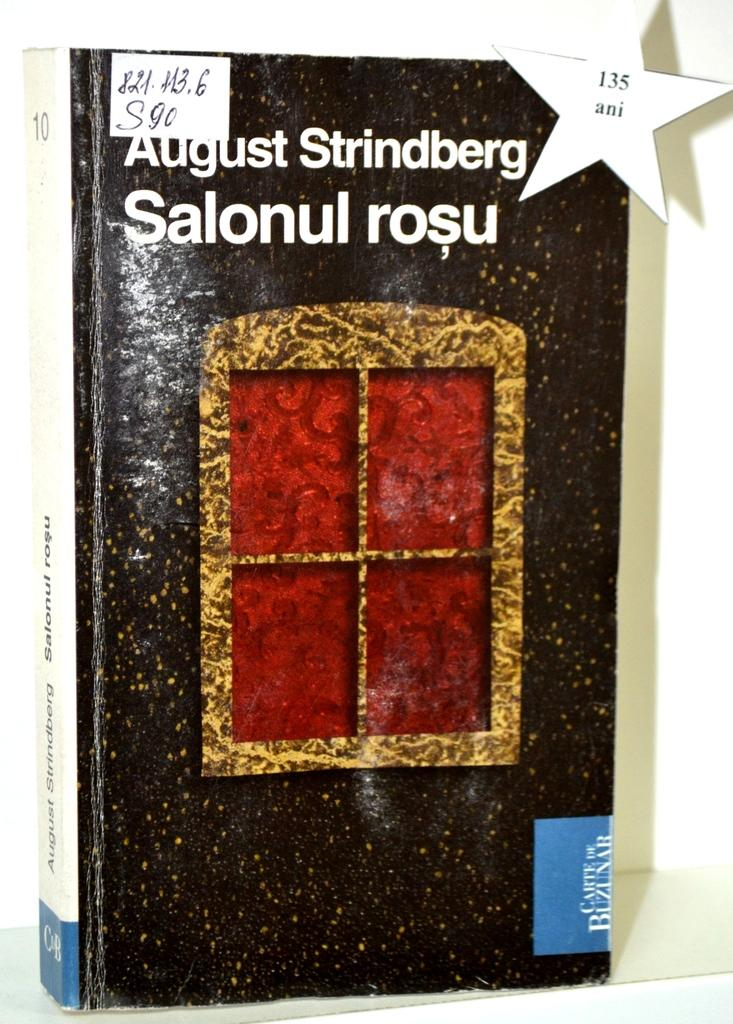<image>
Render a clear and concise summary of the photo. A white star cutout has 135 ani printed on it and adhered to the corner of a book. 